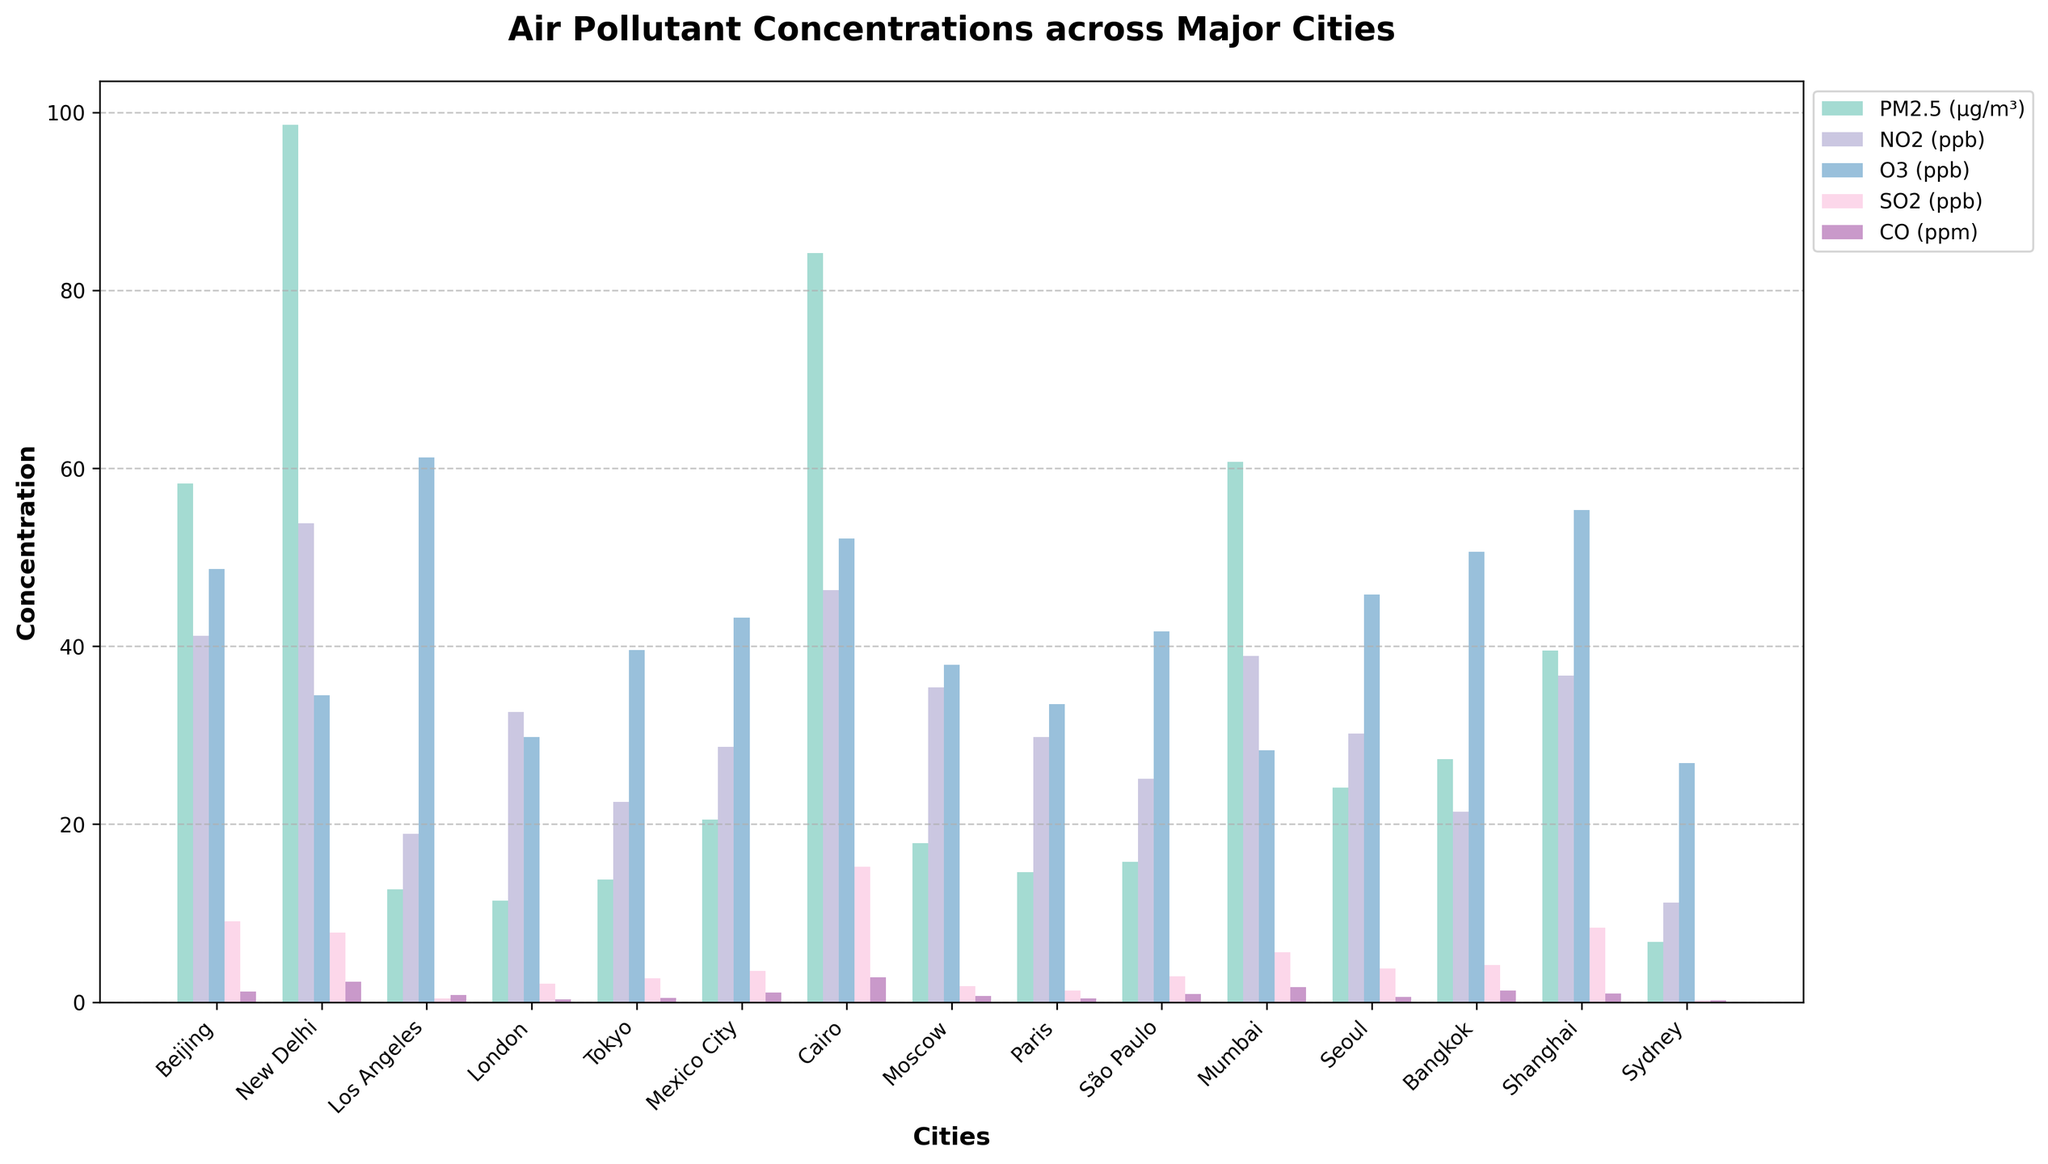What is the city with the highest concentration of PM2.5? By observing the heights of the bars corresponding to PM2.5 (μg/m³) across the cities, it is clear that New Delhi has the highest PM2.5 concentration.
Answer: New Delhi Which city has the lowest concentration of SO2, and what is its value? By comparing the bars for SO2 (ppb) across all cities, Sydney has the lowest concentration at 0.2 ppb.
Answer: Sydney, 0.2 ppb Which city has a higher concentration of NO2, Tokyo or Beijing? By comparing the heights of the NO2 (ppb) bars for Tokyo and Beijing, it is evident that Beijing has a higher NO2 concentration of 41.2 ppb compared to Tokyo's 22.5 ppb.
Answer: Beijing Which city has the highest concentration of CO, and what is its value? By examining the bars for CO (ppm) across all cities, Cairo has the highest CO concentration at 2.8 ppm.
Answer: Cairo, 2.8 ppm What is the total concentration of PM2.5 and NO2 in Mumbai? Adding the PM2.5 concentration of 60.7 μg/m³ and NO2 concentration of 38.9 ppb for Mumbai results in a total concentration of 60.7 + 38.9 = 99.6 units.
Answer: 99.6 units Which city has a higher combined concentration of O3 and SO2, New Delhi or Shanghai? By summing the O3 and SO2 concentrations for both cities, New Delhi has 34.5 (O3) + 7.8 (SO2) = 42.3 units, and Shanghai has 55.3 (O3) + 8.4 (SO2) = 63.7 units. Shanghai has a higher combined concentration.
Answer: Shanghai In which city is the gap between the concentrations of PM2.5 and CO the largest, and what is the difference? Calculating the difference between PM2.5 and CO concentrations for each city, New Delhi has the largest gap: 98.6 (PM2.5) - 2.3 (CO) = 96.3 units.
Answer: New Delhi, 96.3 units Which city has almost equal concentrations of PM2.5 and O3? By visual inspection, Tokyo has nearly equal concentrations of PM2.5 (13.8 μg/m³) and O3 (39.6 ppb) with a smaller difference compared to other cities. This question may be approximate as bars are observed directly.
Answer: Tokyo 